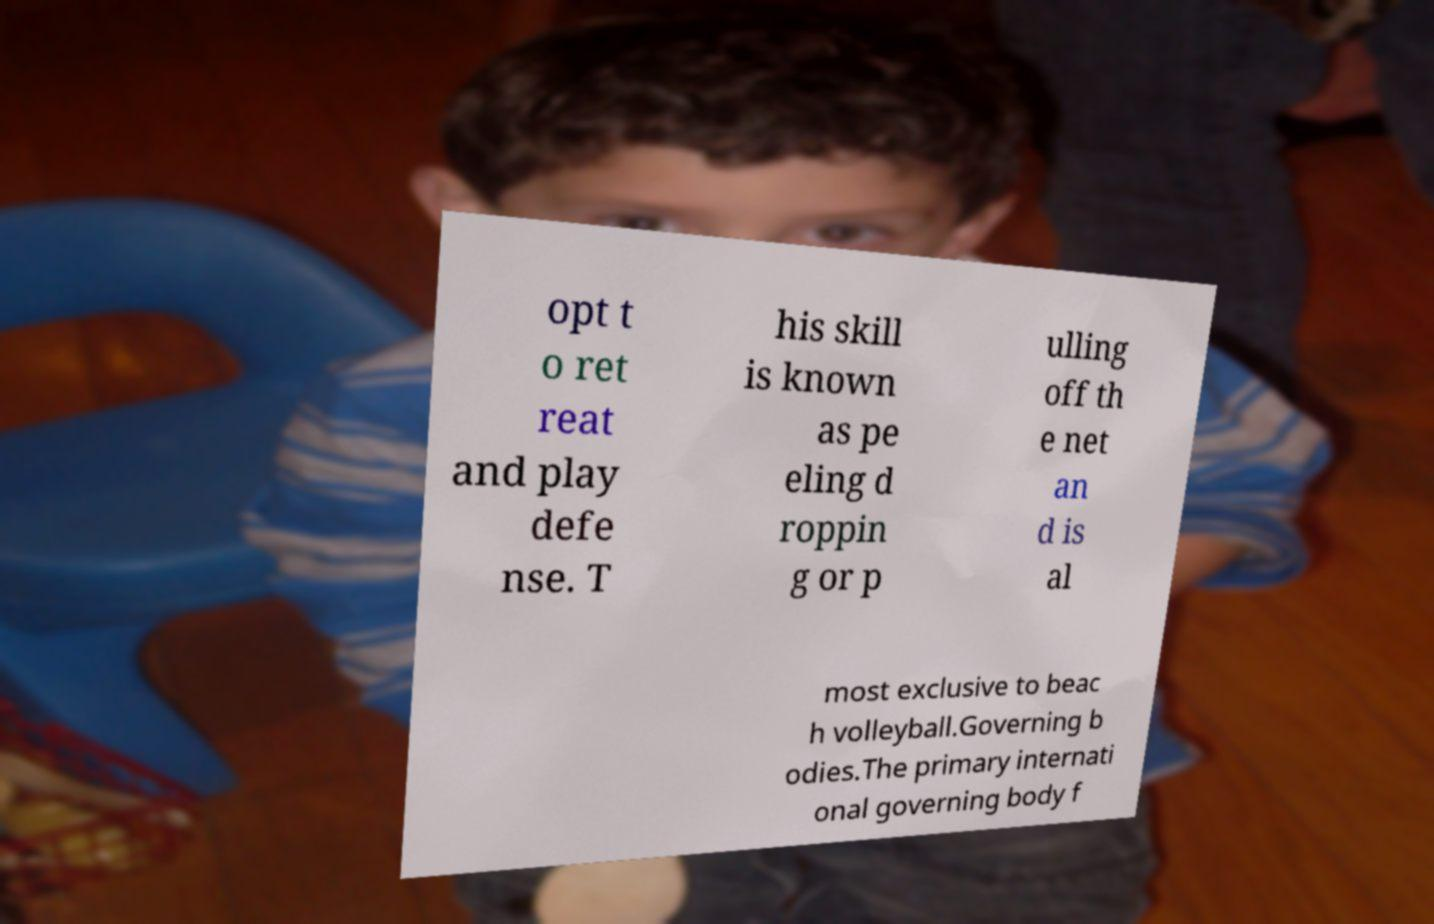There's text embedded in this image that I need extracted. Can you transcribe it verbatim? opt t o ret reat and play defe nse. T his skill is known as pe eling d roppin g or p ulling off th e net an d is al most exclusive to beac h volleyball.Governing b odies.The primary internati onal governing body f 